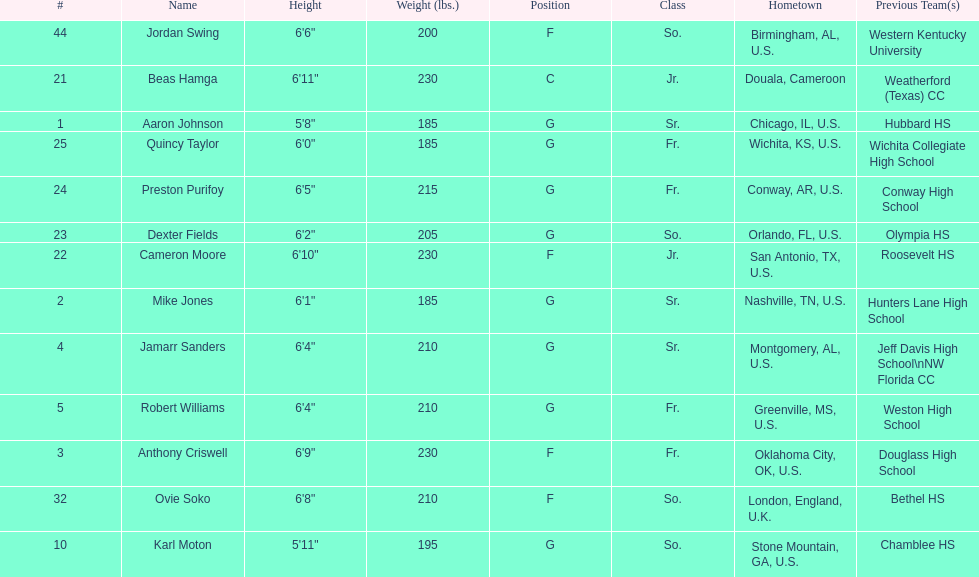Who weighs more, dexter fields or ovie soko? Ovie Soko. 